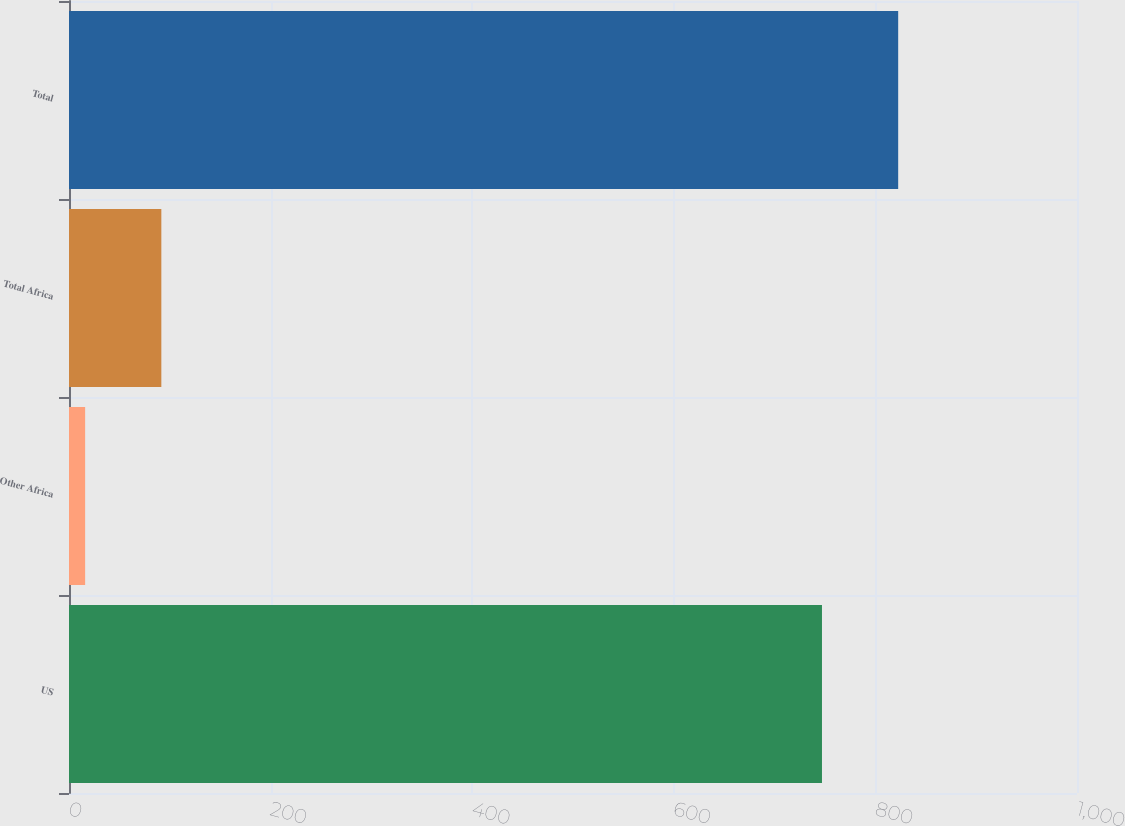Convert chart. <chart><loc_0><loc_0><loc_500><loc_500><bar_chart><fcel>US<fcel>Other Africa<fcel>Total Africa<fcel>Total<nl><fcel>747<fcel>16<fcel>91.6<fcel>822.6<nl></chart> 